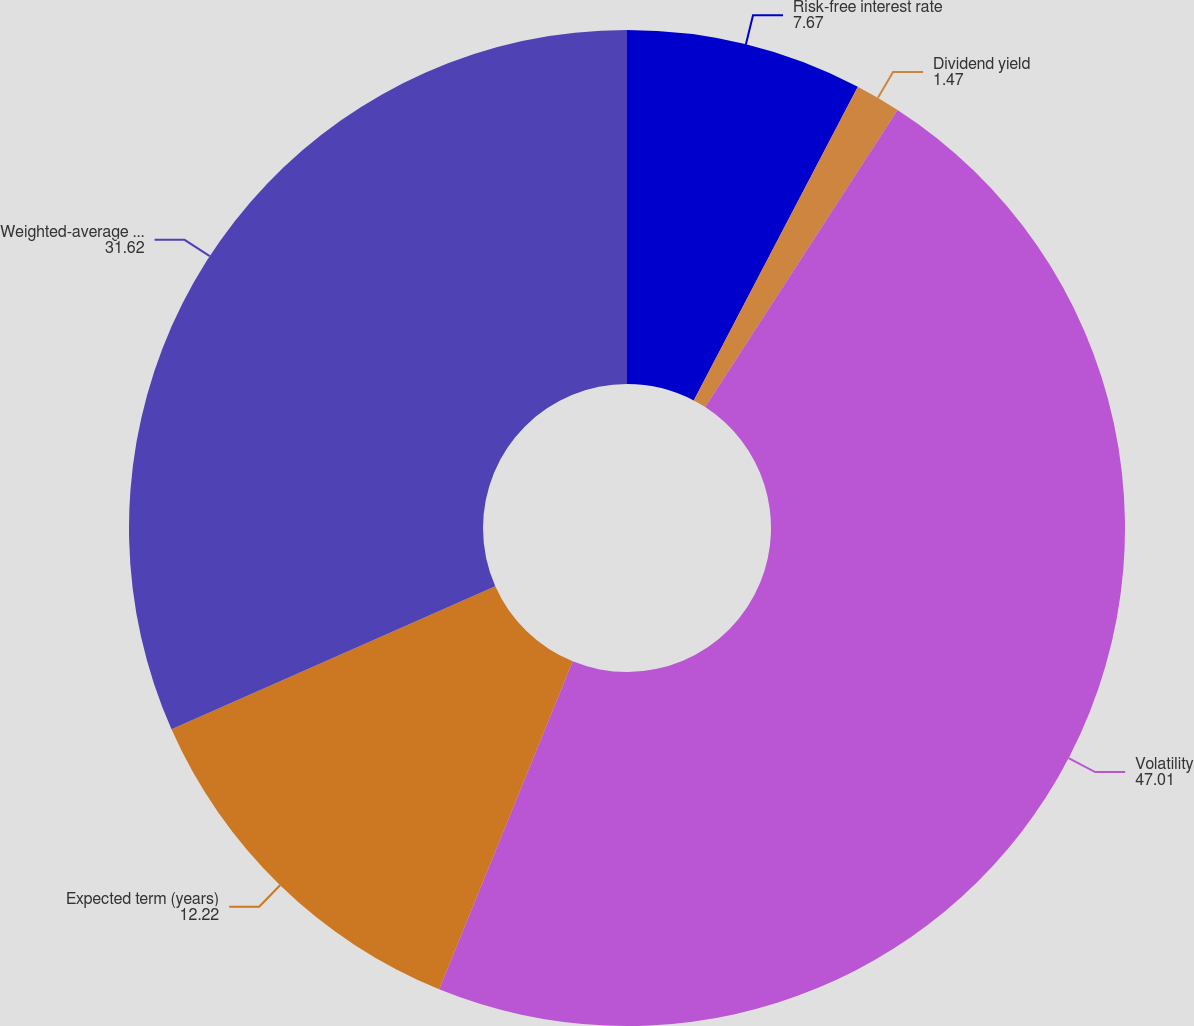Convert chart. <chart><loc_0><loc_0><loc_500><loc_500><pie_chart><fcel>Risk-free interest rate<fcel>Dividend yield<fcel>Volatility<fcel>Expected term (years)<fcel>Weighted-average fair market<nl><fcel>7.67%<fcel>1.47%<fcel>47.01%<fcel>12.22%<fcel>31.62%<nl></chart> 